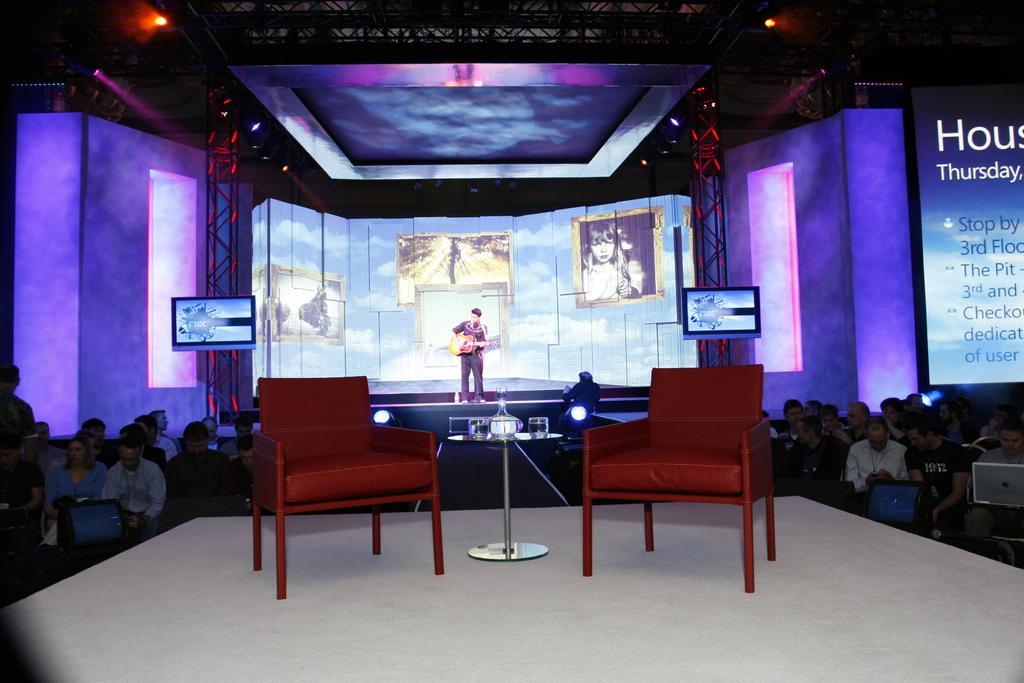Could you give a brief overview of what you see in this image? In the center of the image there is a person playing a guitar and standing on a stage. On the background we can see a projector with a cloudy sky and a photo frame. On the right side there is a banner we can see or read a Thursday. On the right there is a group of people who are sitting on the chair and this person is working on a laptop. On the left side there are another group of people. Here it's a television which is attached to the pole. There are two red chairs and one table in the middle of the image 